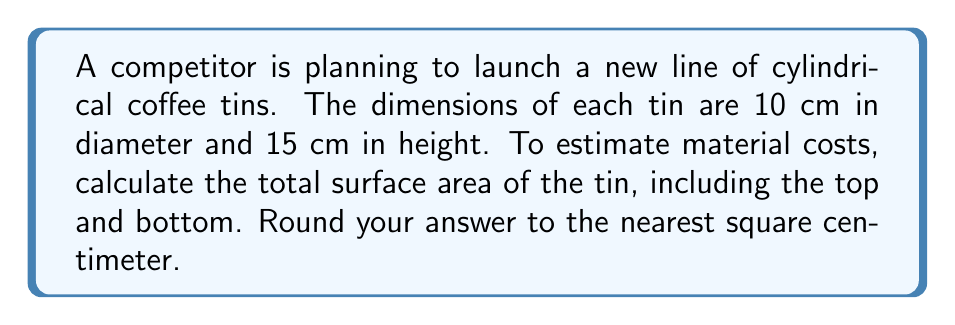Give your solution to this math problem. To solve this problem, we need to calculate the surface area of a cylinder. The surface area of a cylinder consists of three parts:
1. The circular top
2. The circular bottom
3. The curved lateral surface

Let's break it down step by step:

1. Area of the circular top and bottom:
   The area of a circle is given by the formula $A = \pi r^2$
   Diameter = 10 cm, so radius = 5 cm
   Area of one circular face = $\pi (5 \text{ cm})^2 = 25\pi \text{ cm}^2$
   Total area of top and bottom = $2 \times 25\pi \text{ cm}^2 = 50\pi \text{ cm}^2$

2. Area of the curved lateral surface:
   The formula for the lateral surface area of a cylinder is $A = 2\pi rh$
   where $r$ is the radius and $h$ is the height
   Lateral surface area = $2\pi (5 \text{ cm})(15 \text{ cm}) = 150\pi \text{ cm}^2$

3. Total surface area:
   Total surface area = Area of top and bottom + Lateral surface area
   $= 50\pi \text{ cm}^2 + 150\pi \text{ cm}^2 = 200\pi \text{ cm}^2$

4. Converting to a numerical value and rounding:
   $200\pi \approx 628.32 \text{ cm}^2$

Rounding to the nearest square centimeter, we get 628 cm².
Answer: 628 cm² 